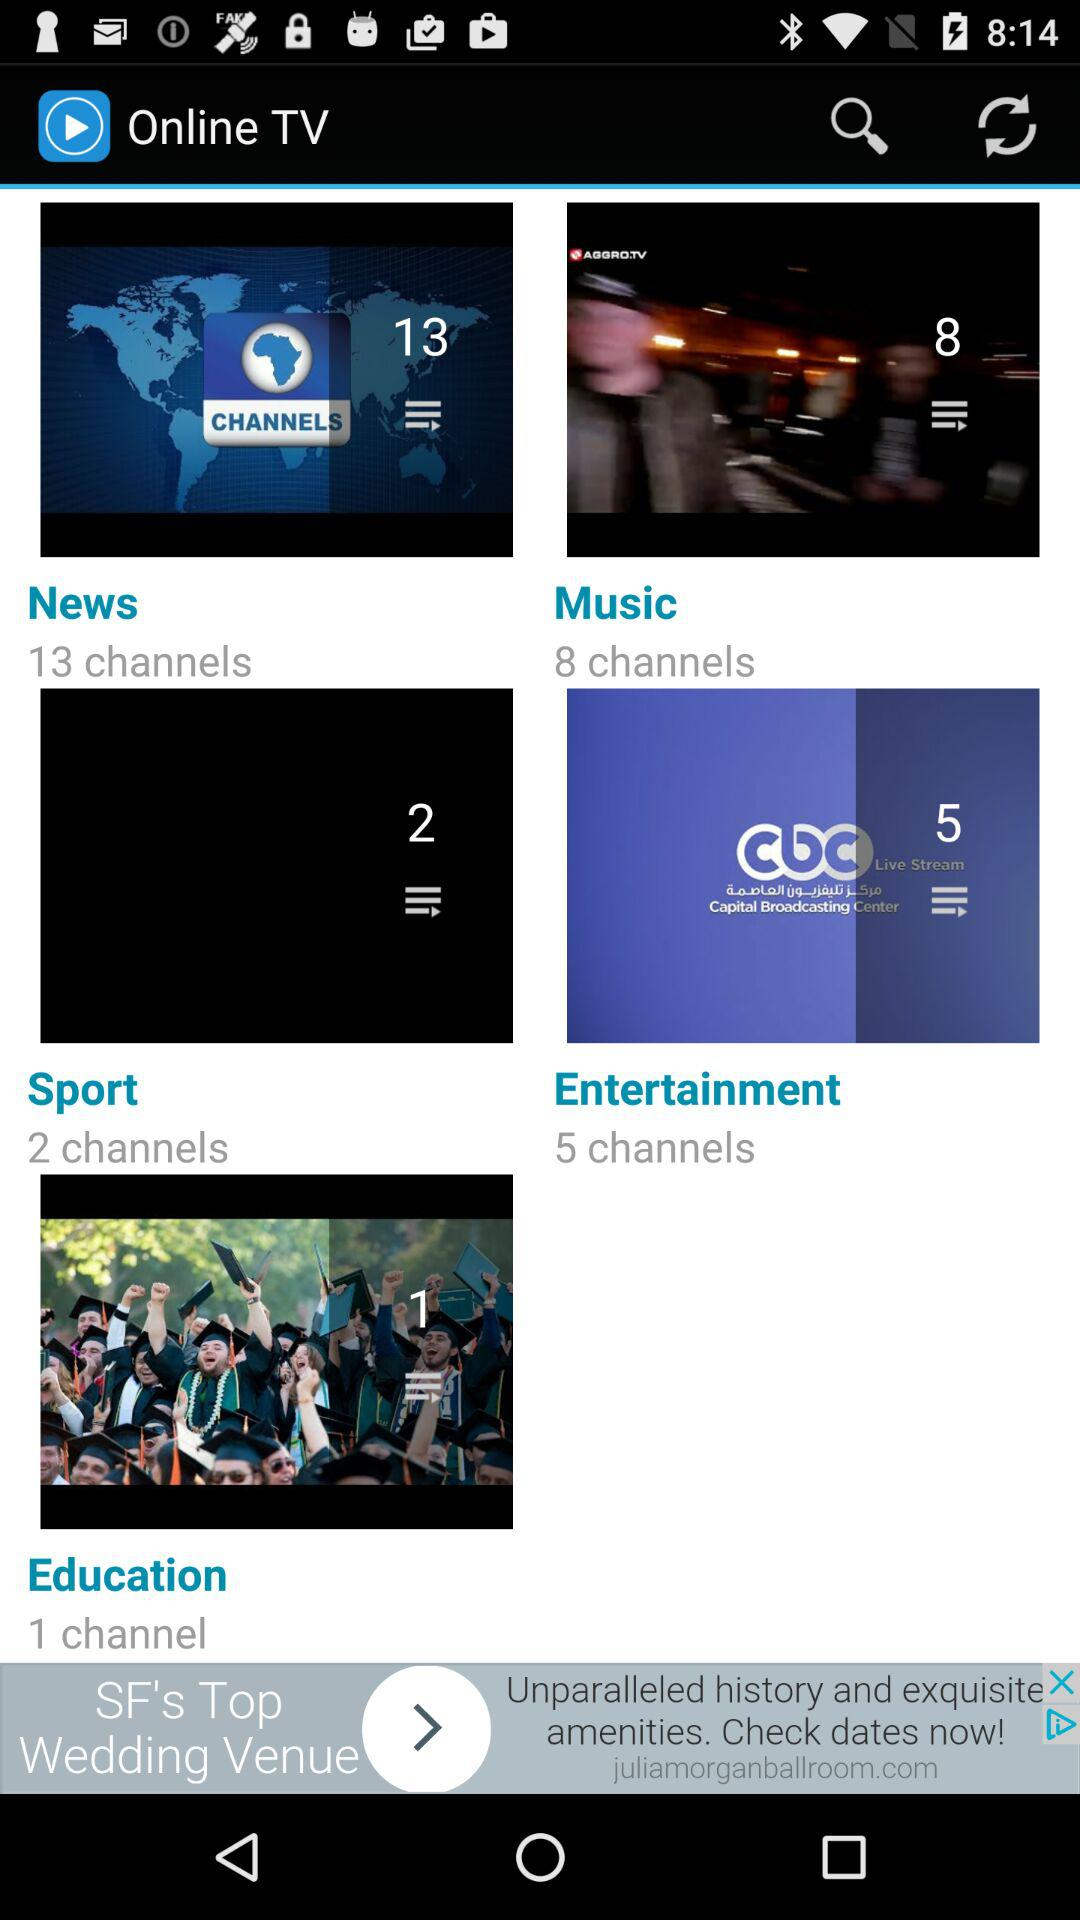What's the total count of sports channels? The total count of sports channels is 2. 